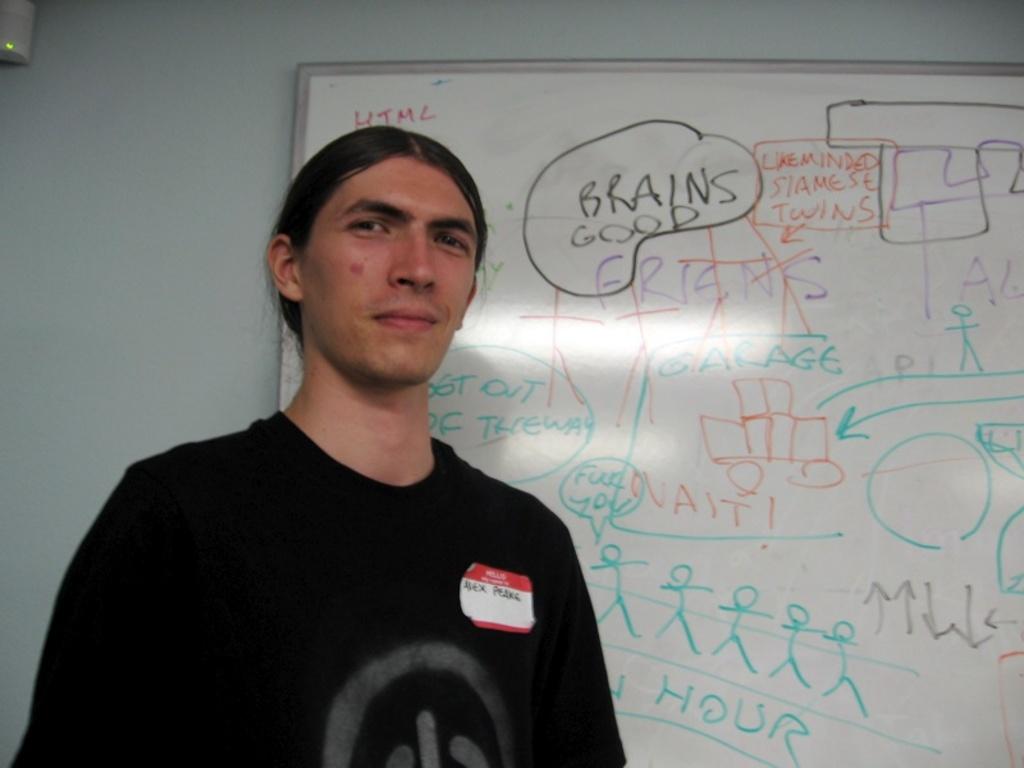What is good?
Provide a short and direct response. Brains. What is on the person's name tage?
Make the answer very short. Alex peake. 